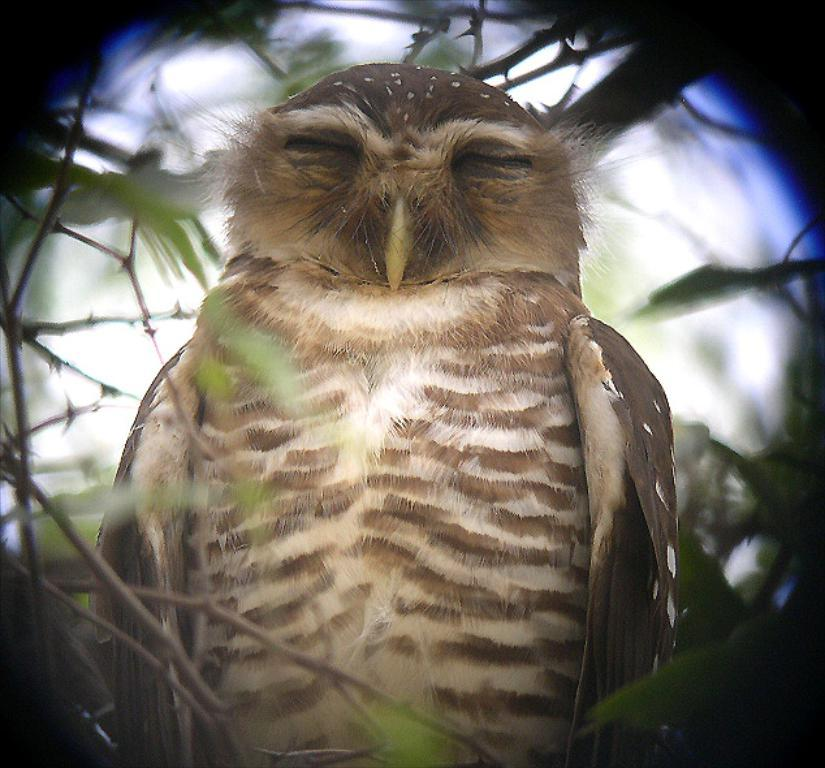What type of animal is in the image? There is an owl in the image. What is the owl sitting on in the image? The owl is sitting on branches in the image. What else can be seen on the branches? There are leaves on the branches in the image. How would you describe the overall lighting in the image? The background of the image is dark. What type of peace offering is the owl holding in the image? There is no peace offering present in the image; it only features an owl sitting on branches with leaves. 